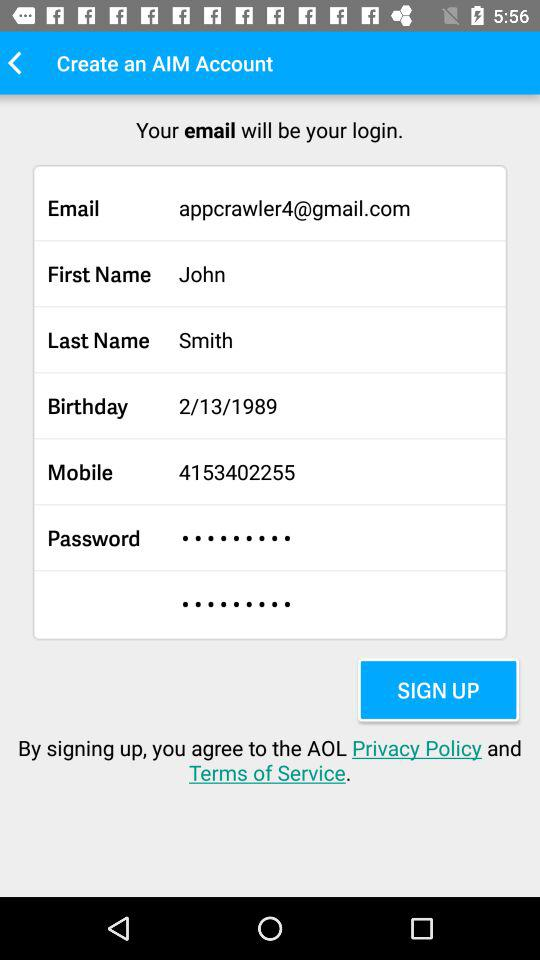What is John's mobile number? John's mobile number is 4153402255. 